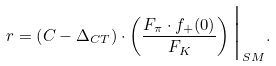Convert formula to latex. <formula><loc_0><loc_0><loc_500><loc_500>r = \left ( C - \Delta _ { C T } \right ) \cdot \left ( \frac { F _ { \pi } \cdot f _ { + } ( 0 ) } { F _ { K } } \right ) \Big { | } _ { S M } .</formula> 